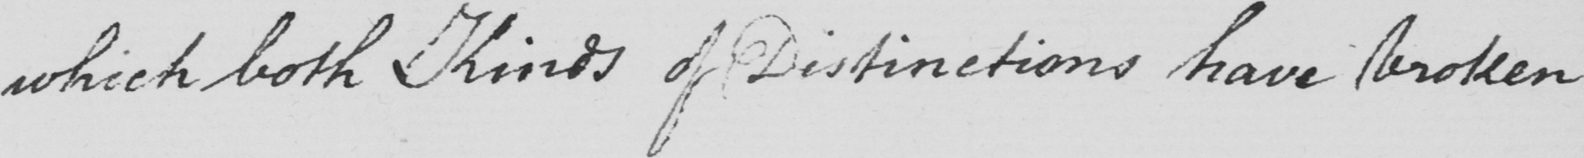Can you tell me what this handwritten text says? which both Kinds of Distinctions have broken 